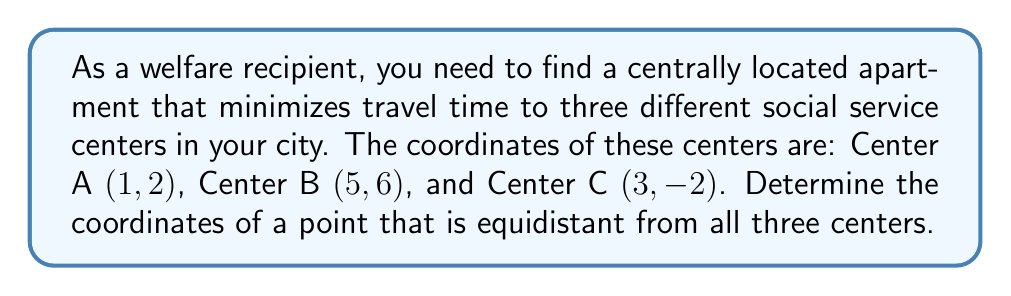Give your solution to this math problem. To find a point equidistant from three given points, we need to determine the center of the circle that passes through all three points. This point is called the circumcenter. We can find it by following these steps:

1) First, we need to find the perpendicular bisectors of any two sides of the triangle formed by the three points. The intersection of these bisectors will give us the circumcenter.

2) Let's choose to find the perpendicular bisectors of sides AB and BC.

3) For side AB:
   Midpoint of AB: $(\frac{1+5}{2}, \frac{2+6}{2}) = (3, 4)$
   Slope of AB: $m_{AB} = \frac{6-2}{5-1} = 1$
   Perpendicular slope: $m_{\perp AB} = -\frac{1}{m_{AB}} = -1$
   Equation of perpendicular bisector of AB: $y - 4 = -1(x - 3)$ or $y = -x + 7$

4) For side BC:
   Midpoint of BC: $(\frac{5+3}{2}, \frac{6-2}{2}) = (4, 2)$
   Slope of BC: $m_{BC} = \frac{-2-6}{3-5} = 4$
   Perpendicular slope: $m_{\perp BC} = -\frac{1}{m_{BC}} = -\frac{1}{4}$
   Equation of perpendicular bisector of BC: $y - 2 = -\frac{1}{4}(x - 4)$ or $y = -\frac{1}{4}x + 3$

5) To find the intersection of these two lines, we solve the system of equations:
   $y = -x + 7$
   $y = -\frac{1}{4}x + 3$

6) Equating these:
   $-x + 7 = -\frac{1}{4}x + 3$
   $-\frac{3}{4}x = -4$
   $x = \frac{16}{3}$

7) Substituting this x-value back into either equation:
   $y = -(\frac{16}{3}) + 7 = \frac{5}{3}$

Therefore, the coordinates of the point equidistant from all three centers are $(\frac{16}{3}, \frac{5}{3})$.

8) To verify, we can calculate the distance from this point to each center using the distance formula:
   $d = \sqrt{(x_2-x_1)^2 + (y_2-y_1)^2}$
   
   The distances should be equal for all three centers.
Answer: The coordinates of the point equidistant from all three social service centers are $(\frac{16}{3}, \frac{5}{3})$ or approximately (5.33, 1.67). 